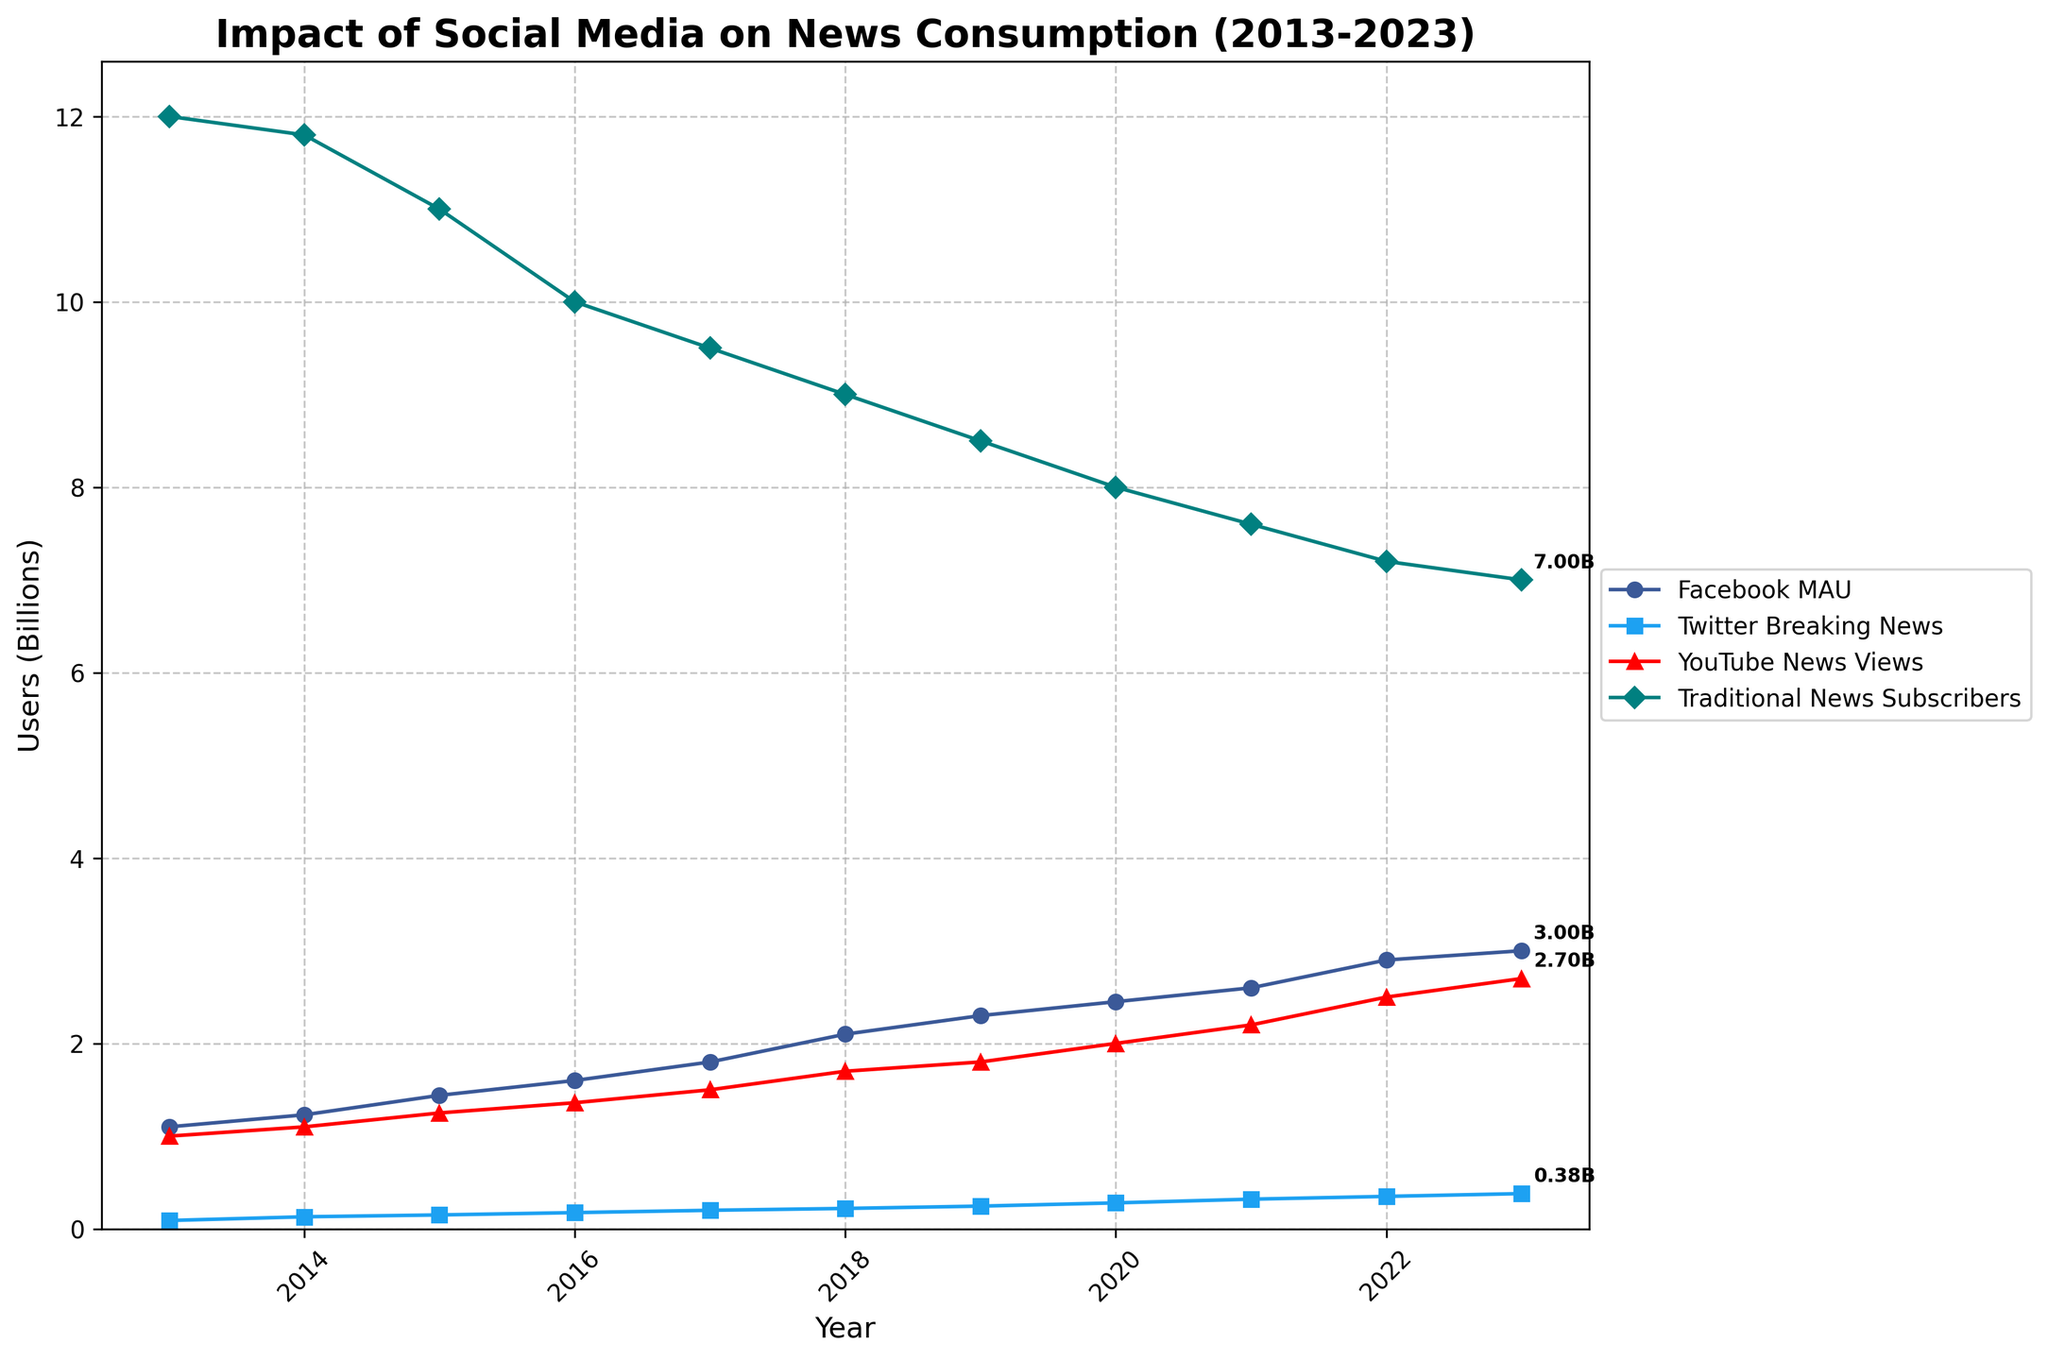What is the title of the plot? The title of the plot is usually displayed at the top center of the figure. In this case, it is written in bold and larger font compared to other texts on the plot.
Answer: Impact of Social Media on News Consumption (2013-2023) How many trend lines are plotted in the figure, and can you name their corresponding data? By looking at the legend on the right side of the plot, you can count and see the names of the trend lines. There are four trend lines, each representing a dataset.
Answer: Four: Facebook MAU, Twitter Breaking News, YouTube News Views, Traditional News Subscribers What is the y-axis label, and what unit does it use? The y-axis label is written parallel to the y-axis, explaining the measure of data being plotted. Here, it mentions the units used as well.
Answer: Users (Billions) Which social media platform had the highest number of users in 2023? By tracing the lines up to the year 2023 on the x-axis, you can see the final values of each trend line. The highest value indicates the most users.
Answer: Facebook How did the number of subscribers to Traditional News Outlets change from 2013 to 2023? You can compare the starting and ending points of the trend line representing Traditional News Outlet Subscribers. The label and y-axis help understand the magnitude of change.
Answer: Decreased from 12 million to 7 million Which platform showed the most consistent user growth over the decade? Consistent growth is indicated by a steady upward trend line. By comparing the overall trends of each line, the one with minimal fluctuations and constant increase shows the most consistent growth.
Answer: Facebook By how much did YouTube News Views increase from 2015 to 2020? Look at the YouTube News Views values for 2015 and 2020, then subtract the 2015 value from the 2020 value.
Answer: 0.75 billion How does the user growth trend of Twitter breaking news compare to Facebook MAU between 2018 and 2023? By comparing the slopes of the two lines from 2018 to 2023, you can see which one had a steeper increase. A steeper slope indicates faster user growth.
Answer: Twitter had faster growth What year did Traditional News Outlets' subscribers drop below 10 million? By examining the Traditional News Outlets' trend line, you can find the point where it first crosses below 10 million on the y-axis.
Answer: 2016 Did any of the social media platforms experience a decline at any point between 2013 and 2023? Check each trend line to see if any of them show a downward slope at any time during the plotted years.
Answer: No 